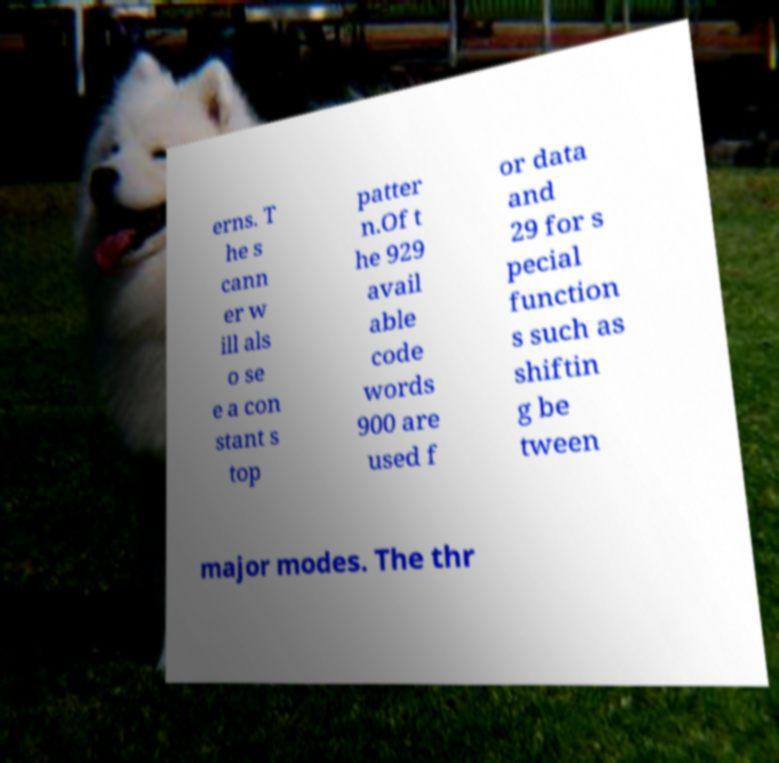Could you extract and type out the text from this image? erns. T he s cann er w ill als o se e a con stant s top patter n.Of t he 929 avail able code words 900 are used f or data and 29 for s pecial function s such as shiftin g be tween major modes. The thr 